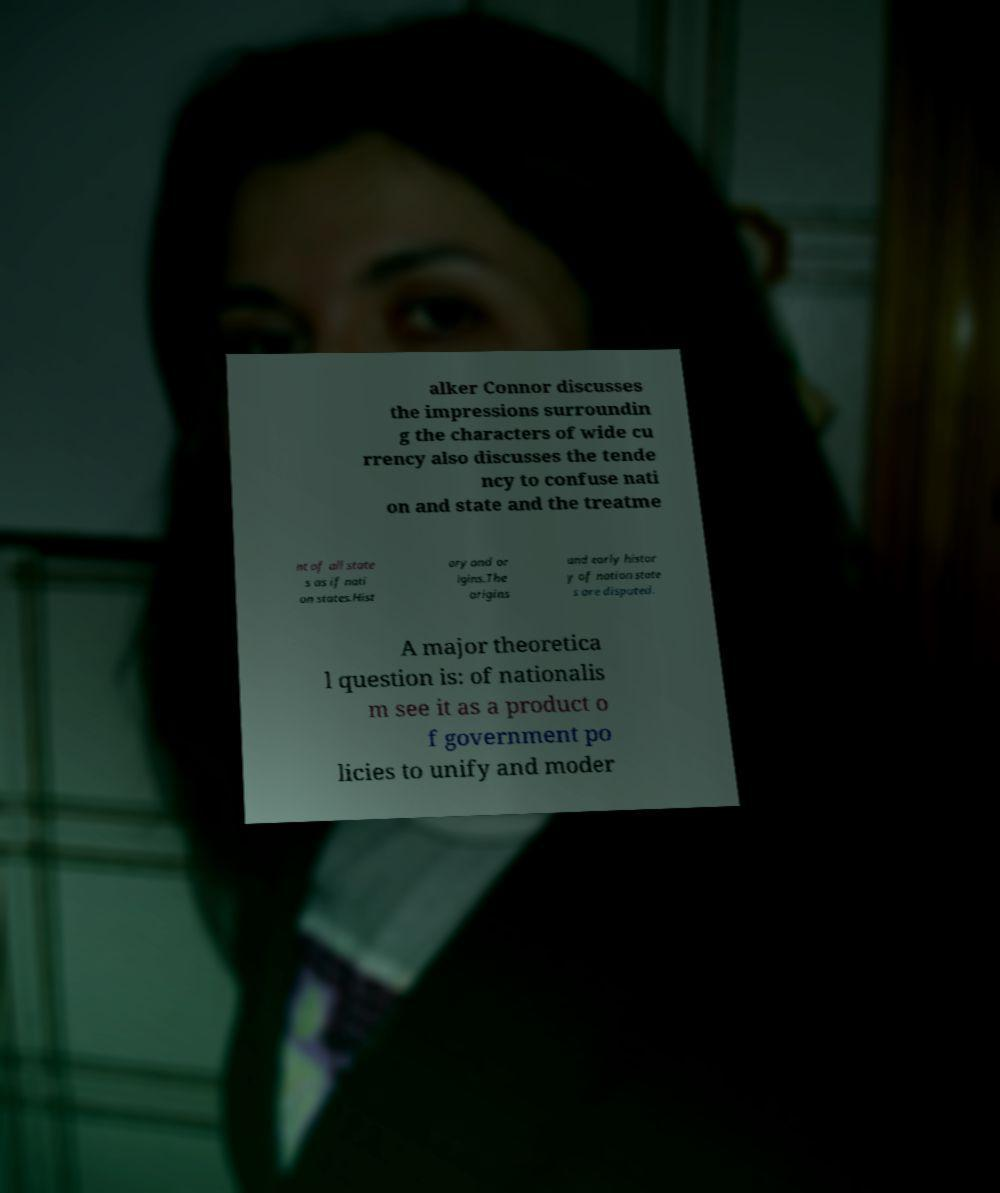Can you read and provide the text displayed in the image?This photo seems to have some interesting text. Can you extract and type it out for me? alker Connor discusses the impressions surroundin g the characters of wide cu rrency also discusses the tende ncy to confuse nati on and state and the treatme nt of all state s as if nati on states.Hist ory and or igins.The origins and early histor y of nation state s are disputed. A major theoretica l question is: of nationalis m see it as a product o f government po licies to unify and moder 